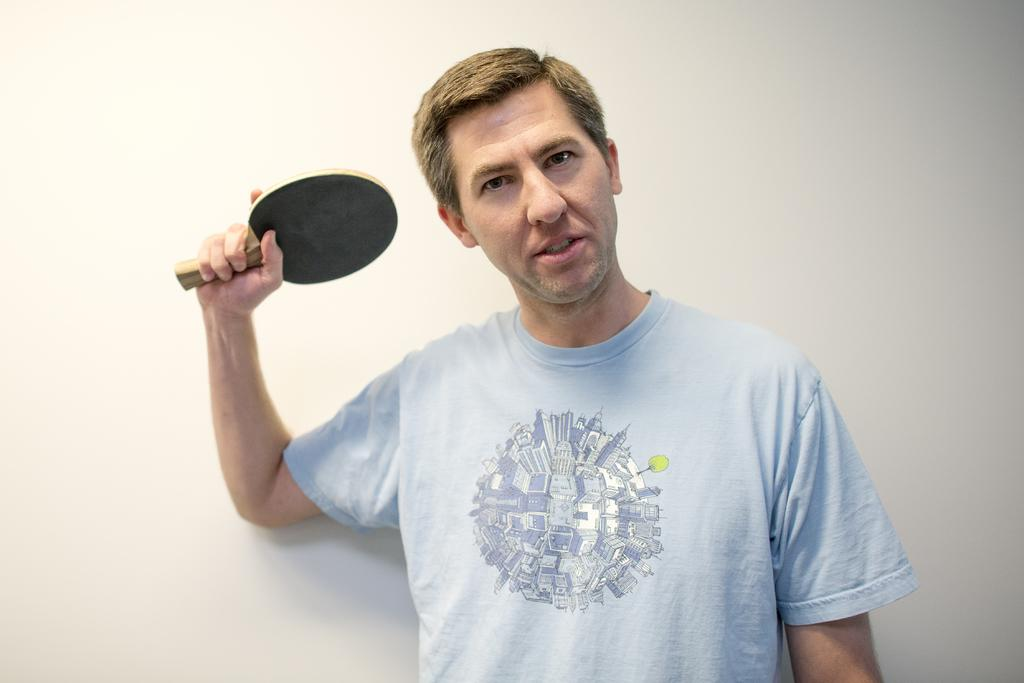What is the main subject of the image? The main subject of the image is a man standing in the center. What is the man wearing in the image? The man is wearing a t-shirt in the image. What object is the man holding in the image? The man is holding a table tennis bat in the image. What can be seen in the background of the image? There is a wall visible in the background of the image. What type of tin can be seen in the image? There is no tin present in the image. Is the man's aunt visible in the image? There is no mention of an aunt in the image, and no such person is visible. --- Facts: 1. There is a group of people sitting on a bench. 2. The people are holding books. 3. There is a tree in the background of the image. 4. The sky is visible in the image. Absurd Topics: horse, ocean, fire Conversation: What is happening in the image? There is a group of people sitting on a bench in the image. What are the people holding in the image? The people are holding books in the image. What can be seen in the background of the image? There is a tree in the background of the image. What is visible above the tree in the image? The sky is visible in the image. Reasoning: Let's think step by step in order to produce the conversation. We start by identifying the main subject of the image, which is the group of people sitting on a bench. Then, we describe what the people are holding, which are books. Next, we mention the background of the image, which is a tree. Finally, we describe what is visible above the tree, which is the sky. Each question is designed to elicit a specific detail about the image that is known from the provided facts. Absurd Question/Answer: Can you see any horses or an ocean in the image? No, there are no horses or ocean visible in the image. Is there a fire burning in the background of the image? No, there is no fire present in the image. 